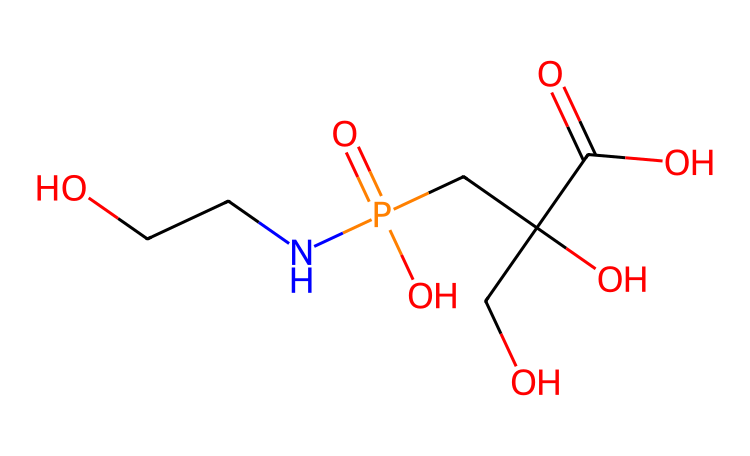What is the molecular formula of glyphosate? To determine the molecular formula, we need to count the atoms present in the SMILES representation. By analyzing the structure, we find that there are carbon (C), hydrogen (H), nitrogen (N), oxygen (O), and phosphorus (P) atoms. The final count results in the molecular formula: C3H8NO5P.
Answer: C3H8NO5P How many oxygen atoms are in glyphosate? From the molecular formula C3H8NO5P, we can see that the number of oxygen atoms is explicitly stated as five (5) in the formula.
Answer: 5 What is the functional group present in glyphosate? Examining the structure, glyphosate contains a carboxylic acid functional group (-COOH) and an amine functional group (-NH2). The presence of these two functional groups is key to its chemical behavior.
Answer: carboxylic acid and amine What is the role of the phosphorus atom in glyphosate? In glyphosate, the phosphorus atom is part of a phosphonate group, which contributes to the herbicide's mechanism of action by affecting the shikimic acid pathway in plants.
Answer: herbicide mechanism How many carbon atoms are in glyphosate? By analyzing the SMILES structure, we count the number of carbon atoms present in the molecular representation. There are three carbon atoms present in glyphosate.
Answer: 3 What type of compound is glyphosate classified as? Glyphosate is classified as a systemic herbicide, affecting plant growth by hindering specific metabolic pathways. This classification is based on its effect on target flora.
Answer: systemic herbicide 